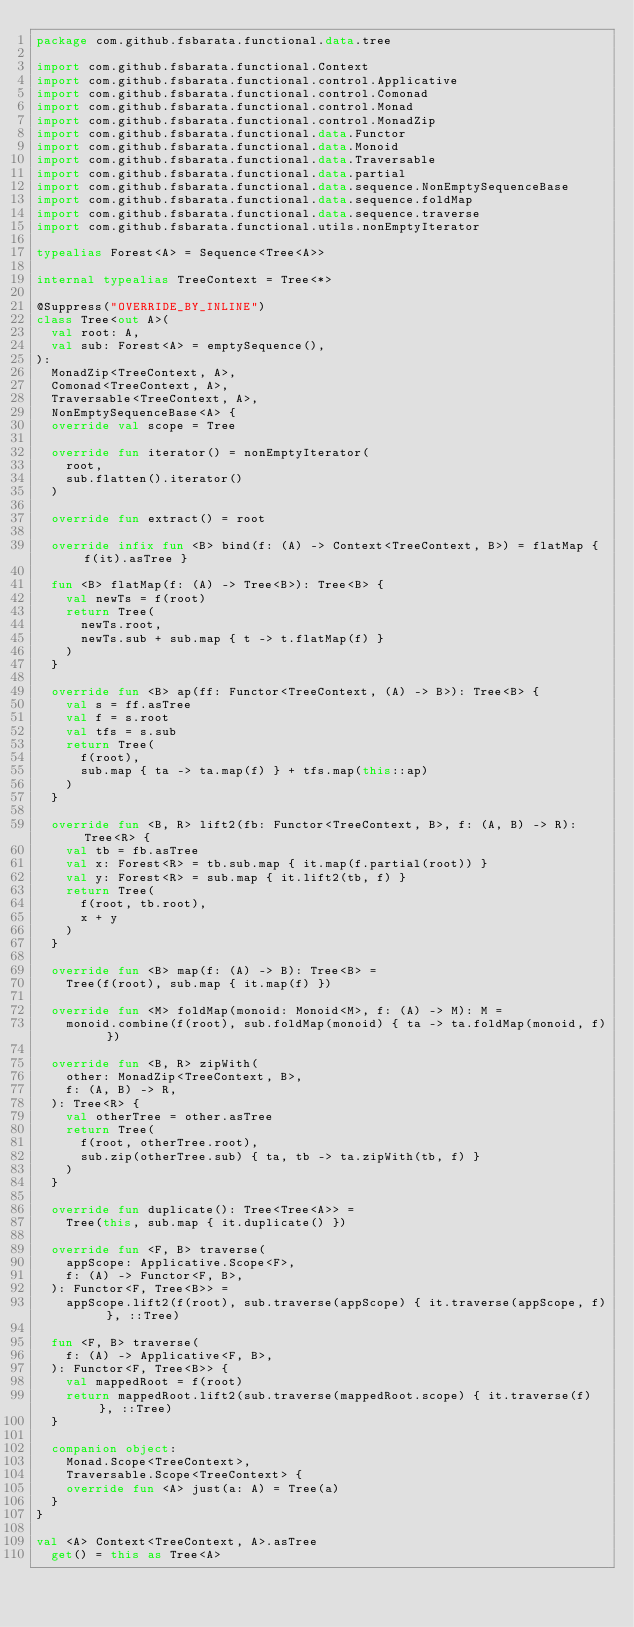Convert code to text. <code><loc_0><loc_0><loc_500><loc_500><_Kotlin_>package com.github.fsbarata.functional.data.tree

import com.github.fsbarata.functional.Context
import com.github.fsbarata.functional.control.Applicative
import com.github.fsbarata.functional.control.Comonad
import com.github.fsbarata.functional.control.Monad
import com.github.fsbarata.functional.control.MonadZip
import com.github.fsbarata.functional.data.Functor
import com.github.fsbarata.functional.data.Monoid
import com.github.fsbarata.functional.data.Traversable
import com.github.fsbarata.functional.data.partial
import com.github.fsbarata.functional.data.sequence.NonEmptySequenceBase
import com.github.fsbarata.functional.data.sequence.foldMap
import com.github.fsbarata.functional.data.sequence.traverse
import com.github.fsbarata.functional.utils.nonEmptyIterator

typealias Forest<A> = Sequence<Tree<A>>

internal typealias TreeContext = Tree<*>

@Suppress("OVERRIDE_BY_INLINE")
class Tree<out A>(
	val root: A,
	val sub: Forest<A> = emptySequence(),
):
	MonadZip<TreeContext, A>,
	Comonad<TreeContext, A>,
	Traversable<TreeContext, A>,
	NonEmptySequenceBase<A> {
	override val scope = Tree

	override fun iterator() = nonEmptyIterator(
		root,
		sub.flatten().iterator()
	)

	override fun extract() = root

	override infix fun <B> bind(f: (A) -> Context<TreeContext, B>) = flatMap { f(it).asTree }

	fun <B> flatMap(f: (A) -> Tree<B>): Tree<B> {
		val newTs = f(root)
		return Tree(
			newTs.root,
			newTs.sub + sub.map { t -> t.flatMap(f) }
		)
	}

	override fun <B> ap(ff: Functor<TreeContext, (A) -> B>): Tree<B> {
		val s = ff.asTree
		val f = s.root
		val tfs = s.sub
		return Tree(
			f(root),
			sub.map { ta -> ta.map(f) } + tfs.map(this::ap)
		)
	}

	override fun <B, R> lift2(fb: Functor<TreeContext, B>, f: (A, B) -> R): Tree<R> {
		val tb = fb.asTree
		val x: Forest<R> = tb.sub.map { it.map(f.partial(root)) }
		val y: Forest<R> = sub.map { it.lift2(tb, f) }
		return Tree(
			f(root, tb.root),
			x + y
		)
	}

	override fun <B> map(f: (A) -> B): Tree<B> =
		Tree(f(root), sub.map { it.map(f) })

	override fun <M> foldMap(monoid: Monoid<M>, f: (A) -> M): M =
		monoid.combine(f(root), sub.foldMap(monoid) { ta -> ta.foldMap(monoid, f) })

	override fun <B, R> zipWith(
		other: MonadZip<TreeContext, B>,
		f: (A, B) -> R,
	): Tree<R> {
		val otherTree = other.asTree
		return Tree(
			f(root, otherTree.root),
			sub.zip(otherTree.sub) { ta, tb -> ta.zipWith(tb, f) }
		)
	}

	override fun duplicate(): Tree<Tree<A>> =
		Tree(this, sub.map { it.duplicate() })

	override fun <F, B> traverse(
		appScope: Applicative.Scope<F>,
		f: (A) -> Functor<F, B>,
	): Functor<F, Tree<B>> =
		appScope.lift2(f(root), sub.traverse(appScope) { it.traverse(appScope, f) }, ::Tree)

	fun <F, B> traverse(
		f: (A) -> Applicative<F, B>,
	): Functor<F, Tree<B>> {
		val mappedRoot = f(root)
		return mappedRoot.lift2(sub.traverse(mappedRoot.scope) { it.traverse(f) }, ::Tree)
	}

	companion object:
		Monad.Scope<TreeContext>,
		Traversable.Scope<TreeContext> {
		override fun <A> just(a: A) = Tree(a)
	}
}

val <A> Context<TreeContext, A>.asTree
	get() = this as Tree<A></code> 